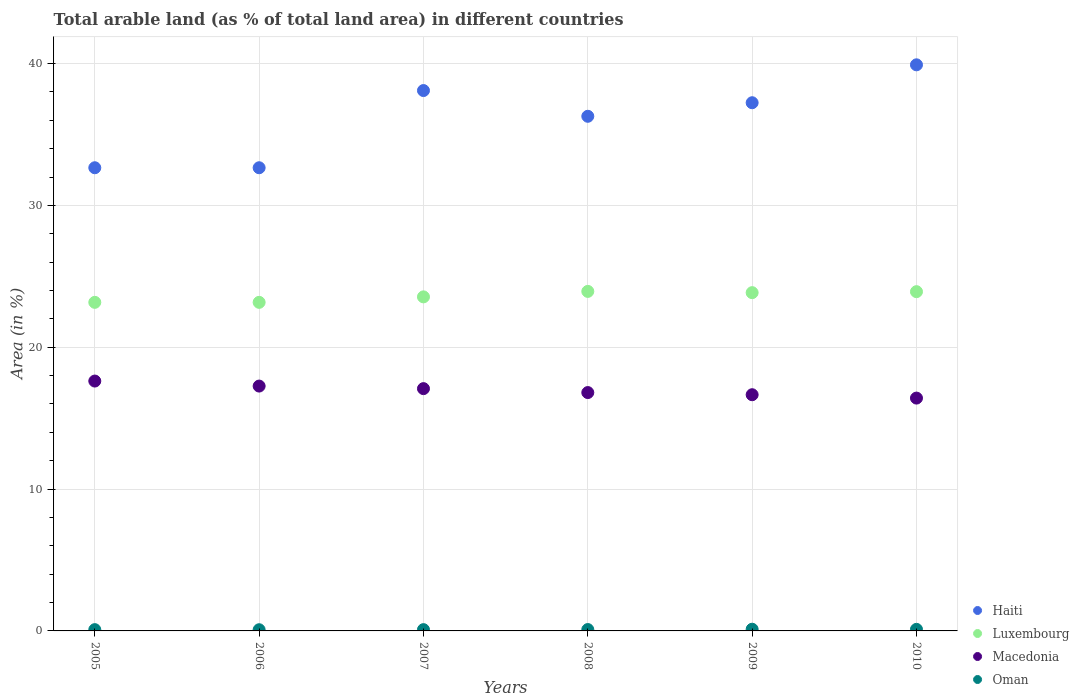What is the percentage of arable land in Oman in 2005?
Offer a very short reply. 0.09. Across all years, what is the maximum percentage of arable land in Haiti?
Make the answer very short. 39.91. Across all years, what is the minimum percentage of arable land in Macedonia?
Your answer should be very brief. 16.42. In which year was the percentage of arable land in Haiti minimum?
Keep it short and to the point. 2005. What is the total percentage of arable land in Luxembourg in the graph?
Keep it short and to the point. 141.59. What is the difference between the percentage of arable land in Luxembourg in 2008 and that in 2010?
Offer a terse response. 0.02. What is the difference between the percentage of arable land in Macedonia in 2007 and the percentage of arable land in Oman in 2009?
Your answer should be compact. 16.96. What is the average percentage of arable land in Luxembourg per year?
Provide a succinct answer. 23.6. In the year 2008, what is the difference between the percentage of arable land in Haiti and percentage of arable land in Macedonia?
Provide a short and direct response. 19.48. What is the ratio of the percentage of arable land in Macedonia in 2008 to that in 2010?
Make the answer very short. 1.02. Is the percentage of arable land in Oman in 2009 less than that in 2010?
Make the answer very short. No. What is the difference between the highest and the second highest percentage of arable land in Luxembourg?
Make the answer very short. 0.02. What is the difference between the highest and the lowest percentage of arable land in Haiti?
Your response must be concise. 7.26. In how many years, is the percentage of arable land in Macedonia greater than the average percentage of arable land in Macedonia taken over all years?
Ensure brevity in your answer.  3. Is it the case that in every year, the sum of the percentage of arable land in Macedonia and percentage of arable land in Luxembourg  is greater than the sum of percentage of arable land in Haiti and percentage of arable land in Oman?
Make the answer very short. Yes. Is it the case that in every year, the sum of the percentage of arable land in Oman and percentage of arable land in Haiti  is greater than the percentage of arable land in Luxembourg?
Your response must be concise. Yes. Does the percentage of arable land in Oman monotonically increase over the years?
Your answer should be compact. No. Is the percentage of arable land in Haiti strictly greater than the percentage of arable land in Luxembourg over the years?
Provide a short and direct response. Yes. Is the percentage of arable land in Oman strictly less than the percentage of arable land in Haiti over the years?
Make the answer very short. Yes. Does the graph contain any zero values?
Keep it short and to the point. No. Does the graph contain grids?
Keep it short and to the point. Yes. How many legend labels are there?
Offer a terse response. 4. What is the title of the graph?
Provide a succinct answer. Total arable land (as % of total land area) in different countries. Does "Guinea" appear as one of the legend labels in the graph?
Your answer should be very brief. No. What is the label or title of the Y-axis?
Give a very brief answer. Area (in %). What is the Area (in %) of Haiti in 2005?
Ensure brevity in your answer.  32.66. What is the Area (in %) of Luxembourg in 2005?
Offer a very short reply. 23.17. What is the Area (in %) in Macedonia in 2005?
Give a very brief answer. 17.62. What is the Area (in %) of Oman in 2005?
Your answer should be compact. 0.09. What is the Area (in %) in Haiti in 2006?
Your answer should be compact. 32.66. What is the Area (in %) in Luxembourg in 2006?
Your answer should be very brief. 23.17. What is the Area (in %) of Macedonia in 2006?
Provide a succinct answer. 17.26. What is the Area (in %) of Oman in 2006?
Your response must be concise. 0.08. What is the Area (in %) in Haiti in 2007?
Make the answer very short. 38.1. What is the Area (in %) in Luxembourg in 2007?
Provide a succinct answer. 23.55. What is the Area (in %) in Macedonia in 2007?
Make the answer very short. 17.08. What is the Area (in %) of Oman in 2007?
Your response must be concise. 0.09. What is the Area (in %) in Haiti in 2008?
Keep it short and to the point. 36.28. What is the Area (in %) in Luxembourg in 2008?
Offer a very short reply. 23.94. What is the Area (in %) in Macedonia in 2008?
Keep it short and to the point. 16.81. What is the Area (in %) in Oman in 2008?
Provide a short and direct response. 0.1. What is the Area (in %) in Haiti in 2009?
Your answer should be very brief. 37.24. What is the Area (in %) in Luxembourg in 2009?
Your answer should be compact. 23.85. What is the Area (in %) of Macedonia in 2009?
Offer a very short reply. 16.65. What is the Area (in %) of Oman in 2009?
Offer a terse response. 0.12. What is the Area (in %) in Haiti in 2010?
Your response must be concise. 39.91. What is the Area (in %) of Luxembourg in 2010?
Provide a succinct answer. 23.92. What is the Area (in %) in Macedonia in 2010?
Provide a succinct answer. 16.42. What is the Area (in %) in Oman in 2010?
Ensure brevity in your answer.  0.11. Across all years, what is the maximum Area (in %) of Haiti?
Offer a very short reply. 39.91. Across all years, what is the maximum Area (in %) of Luxembourg?
Offer a very short reply. 23.94. Across all years, what is the maximum Area (in %) of Macedonia?
Make the answer very short. 17.62. Across all years, what is the maximum Area (in %) of Oman?
Give a very brief answer. 0.12. Across all years, what is the minimum Area (in %) of Haiti?
Keep it short and to the point. 32.66. Across all years, what is the minimum Area (in %) in Luxembourg?
Keep it short and to the point. 23.17. Across all years, what is the minimum Area (in %) in Macedonia?
Your answer should be compact. 16.42. Across all years, what is the minimum Area (in %) in Oman?
Make the answer very short. 0.08. What is the total Area (in %) of Haiti in the graph?
Offer a terse response. 216.85. What is the total Area (in %) of Luxembourg in the graph?
Make the answer very short. 141.59. What is the total Area (in %) in Macedonia in the graph?
Offer a very short reply. 101.84. What is the total Area (in %) of Oman in the graph?
Make the answer very short. 0.59. What is the difference between the Area (in %) of Haiti in 2005 and that in 2006?
Make the answer very short. 0. What is the difference between the Area (in %) in Luxembourg in 2005 and that in 2006?
Offer a terse response. 0. What is the difference between the Area (in %) of Macedonia in 2005 and that in 2006?
Provide a short and direct response. 0.35. What is the difference between the Area (in %) in Oman in 2005 and that in 2006?
Your answer should be very brief. 0.01. What is the difference between the Area (in %) in Haiti in 2005 and that in 2007?
Offer a very short reply. -5.44. What is the difference between the Area (in %) in Luxembourg in 2005 and that in 2007?
Your answer should be compact. -0.39. What is the difference between the Area (in %) in Macedonia in 2005 and that in 2007?
Ensure brevity in your answer.  0.53. What is the difference between the Area (in %) in Oman in 2005 and that in 2007?
Offer a terse response. 0. What is the difference between the Area (in %) in Haiti in 2005 and that in 2008?
Provide a succinct answer. -3.63. What is the difference between the Area (in %) in Luxembourg in 2005 and that in 2008?
Offer a terse response. -0.77. What is the difference between the Area (in %) in Macedonia in 2005 and that in 2008?
Keep it short and to the point. 0.81. What is the difference between the Area (in %) of Oman in 2005 and that in 2008?
Give a very brief answer. -0.01. What is the difference between the Area (in %) in Haiti in 2005 and that in 2009?
Offer a very short reply. -4.58. What is the difference between the Area (in %) in Luxembourg in 2005 and that in 2009?
Your answer should be compact. -0.68. What is the difference between the Area (in %) in Macedonia in 2005 and that in 2009?
Keep it short and to the point. 0.96. What is the difference between the Area (in %) of Oman in 2005 and that in 2009?
Your answer should be very brief. -0.03. What is the difference between the Area (in %) in Haiti in 2005 and that in 2010?
Your response must be concise. -7.26. What is the difference between the Area (in %) in Luxembourg in 2005 and that in 2010?
Your response must be concise. -0.75. What is the difference between the Area (in %) in Macedonia in 2005 and that in 2010?
Your answer should be compact. 1.2. What is the difference between the Area (in %) of Oman in 2005 and that in 2010?
Offer a terse response. -0.02. What is the difference between the Area (in %) in Haiti in 2006 and that in 2007?
Keep it short and to the point. -5.44. What is the difference between the Area (in %) in Luxembourg in 2006 and that in 2007?
Make the answer very short. -0.39. What is the difference between the Area (in %) of Macedonia in 2006 and that in 2007?
Ensure brevity in your answer.  0.18. What is the difference between the Area (in %) of Oman in 2006 and that in 2007?
Provide a short and direct response. -0.01. What is the difference between the Area (in %) in Haiti in 2006 and that in 2008?
Ensure brevity in your answer.  -3.63. What is the difference between the Area (in %) of Luxembourg in 2006 and that in 2008?
Ensure brevity in your answer.  -0.77. What is the difference between the Area (in %) in Macedonia in 2006 and that in 2008?
Your answer should be very brief. 0.46. What is the difference between the Area (in %) in Oman in 2006 and that in 2008?
Provide a short and direct response. -0.01. What is the difference between the Area (in %) in Haiti in 2006 and that in 2009?
Ensure brevity in your answer.  -4.58. What is the difference between the Area (in %) in Luxembourg in 2006 and that in 2009?
Provide a short and direct response. -0.68. What is the difference between the Area (in %) in Macedonia in 2006 and that in 2009?
Give a very brief answer. 0.61. What is the difference between the Area (in %) of Oman in 2006 and that in 2009?
Offer a terse response. -0.04. What is the difference between the Area (in %) in Haiti in 2006 and that in 2010?
Make the answer very short. -7.26. What is the difference between the Area (in %) of Luxembourg in 2006 and that in 2010?
Keep it short and to the point. -0.75. What is the difference between the Area (in %) of Macedonia in 2006 and that in 2010?
Provide a succinct answer. 0.85. What is the difference between the Area (in %) in Oman in 2006 and that in 2010?
Keep it short and to the point. -0.03. What is the difference between the Area (in %) of Haiti in 2007 and that in 2008?
Your answer should be compact. 1.81. What is the difference between the Area (in %) of Luxembourg in 2007 and that in 2008?
Your response must be concise. -0.39. What is the difference between the Area (in %) in Macedonia in 2007 and that in 2008?
Provide a succinct answer. 0.28. What is the difference between the Area (in %) of Oman in 2007 and that in 2008?
Ensure brevity in your answer.  -0.01. What is the difference between the Area (in %) in Haiti in 2007 and that in 2009?
Provide a short and direct response. 0.86. What is the difference between the Area (in %) of Luxembourg in 2007 and that in 2009?
Offer a very short reply. -0.3. What is the difference between the Area (in %) of Macedonia in 2007 and that in 2009?
Ensure brevity in your answer.  0.43. What is the difference between the Area (in %) of Oman in 2007 and that in 2009?
Offer a very short reply. -0.03. What is the difference between the Area (in %) of Haiti in 2007 and that in 2010?
Your response must be concise. -1.81. What is the difference between the Area (in %) of Luxembourg in 2007 and that in 2010?
Provide a short and direct response. -0.37. What is the difference between the Area (in %) of Macedonia in 2007 and that in 2010?
Ensure brevity in your answer.  0.67. What is the difference between the Area (in %) in Oman in 2007 and that in 2010?
Offer a terse response. -0.02. What is the difference between the Area (in %) in Haiti in 2008 and that in 2009?
Your response must be concise. -0.96. What is the difference between the Area (in %) in Luxembourg in 2008 and that in 2009?
Offer a very short reply. 0.09. What is the difference between the Area (in %) in Macedonia in 2008 and that in 2009?
Ensure brevity in your answer.  0.15. What is the difference between the Area (in %) in Oman in 2008 and that in 2009?
Provide a succinct answer. -0.02. What is the difference between the Area (in %) in Haiti in 2008 and that in 2010?
Offer a very short reply. -3.63. What is the difference between the Area (in %) in Luxembourg in 2008 and that in 2010?
Ensure brevity in your answer.  0.02. What is the difference between the Area (in %) of Macedonia in 2008 and that in 2010?
Provide a short and direct response. 0.39. What is the difference between the Area (in %) of Oman in 2008 and that in 2010?
Your answer should be compact. -0.01. What is the difference between the Area (in %) of Haiti in 2009 and that in 2010?
Offer a very short reply. -2.67. What is the difference between the Area (in %) in Luxembourg in 2009 and that in 2010?
Provide a succinct answer. -0.07. What is the difference between the Area (in %) in Macedonia in 2009 and that in 2010?
Keep it short and to the point. 0.24. What is the difference between the Area (in %) in Oman in 2009 and that in 2010?
Offer a very short reply. 0.01. What is the difference between the Area (in %) in Haiti in 2005 and the Area (in %) in Luxembourg in 2006?
Keep it short and to the point. 9.49. What is the difference between the Area (in %) of Haiti in 2005 and the Area (in %) of Macedonia in 2006?
Provide a short and direct response. 15.39. What is the difference between the Area (in %) of Haiti in 2005 and the Area (in %) of Oman in 2006?
Give a very brief answer. 32.57. What is the difference between the Area (in %) of Luxembourg in 2005 and the Area (in %) of Macedonia in 2006?
Your answer should be very brief. 5.9. What is the difference between the Area (in %) in Luxembourg in 2005 and the Area (in %) in Oman in 2006?
Provide a succinct answer. 23.08. What is the difference between the Area (in %) of Macedonia in 2005 and the Area (in %) of Oman in 2006?
Keep it short and to the point. 17.53. What is the difference between the Area (in %) in Haiti in 2005 and the Area (in %) in Luxembourg in 2007?
Ensure brevity in your answer.  9.1. What is the difference between the Area (in %) in Haiti in 2005 and the Area (in %) in Macedonia in 2007?
Make the answer very short. 15.57. What is the difference between the Area (in %) of Haiti in 2005 and the Area (in %) of Oman in 2007?
Offer a very short reply. 32.57. What is the difference between the Area (in %) of Luxembourg in 2005 and the Area (in %) of Macedonia in 2007?
Your response must be concise. 6.08. What is the difference between the Area (in %) in Luxembourg in 2005 and the Area (in %) in Oman in 2007?
Ensure brevity in your answer.  23.08. What is the difference between the Area (in %) in Macedonia in 2005 and the Area (in %) in Oman in 2007?
Keep it short and to the point. 17.53. What is the difference between the Area (in %) in Haiti in 2005 and the Area (in %) in Luxembourg in 2008?
Make the answer very short. 8.72. What is the difference between the Area (in %) in Haiti in 2005 and the Area (in %) in Macedonia in 2008?
Keep it short and to the point. 15.85. What is the difference between the Area (in %) of Haiti in 2005 and the Area (in %) of Oman in 2008?
Keep it short and to the point. 32.56. What is the difference between the Area (in %) of Luxembourg in 2005 and the Area (in %) of Macedonia in 2008?
Offer a terse response. 6.36. What is the difference between the Area (in %) in Luxembourg in 2005 and the Area (in %) in Oman in 2008?
Your response must be concise. 23.07. What is the difference between the Area (in %) in Macedonia in 2005 and the Area (in %) in Oman in 2008?
Provide a succinct answer. 17.52. What is the difference between the Area (in %) in Haiti in 2005 and the Area (in %) in Luxembourg in 2009?
Give a very brief answer. 8.81. What is the difference between the Area (in %) of Haiti in 2005 and the Area (in %) of Macedonia in 2009?
Your answer should be compact. 16. What is the difference between the Area (in %) of Haiti in 2005 and the Area (in %) of Oman in 2009?
Provide a short and direct response. 32.54. What is the difference between the Area (in %) of Luxembourg in 2005 and the Area (in %) of Macedonia in 2009?
Ensure brevity in your answer.  6.51. What is the difference between the Area (in %) of Luxembourg in 2005 and the Area (in %) of Oman in 2009?
Make the answer very short. 23.05. What is the difference between the Area (in %) of Macedonia in 2005 and the Area (in %) of Oman in 2009?
Your answer should be compact. 17.5. What is the difference between the Area (in %) of Haiti in 2005 and the Area (in %) of Luxembourg in 2010?
Give a very brief answer. 8.74. What is the difference between the Area (in %) in Haiti in 2005 and the Area (in %) in Macedonia in 2010?
Ensure brevity in your answer.  16.24. What is the difference between the Area (in %) of Haiti in 2005 and the Area (in %) of Oman in 2010?
Make the answer very short. 32.55. What is the difference between the Area (in %) in Luxembourg in 2005 and the Area (in %) in Macedonia in 2010?
Offer a very short reply. 6.75. What is the difference between the Area (in %) in Luxembourg in 2005 and the Area (in %) in Oman in 2010?
Offer a terse response. 23.06. What is the difference between the Area (in %) of Macedonia in 2005 and the Area (in %) of Oman in 2010?
Your answer should be very brief. 17.51. What is the difference between the Area (in %) in Haiti in 2006 and the Area (in %) in Luxembourg in 2007?
Ensure brevity in your answer.  9.1. What is the difference between the Area (in %) of Haiti in 2006 and the Area (in %) of Macedonia in 2007?
Your answer should be very brief. 15.57. What is the difference between the Area (in %) in Haiti in 2006 and the Area (in %) in Oman in 2007?
Your answer should be compact. 32.57. What is the difference between the Area (in %) in Luxembourg in 2006 and the Area (in %) in Macedonia in 2007?
Offer a very short reply. 6.08. What is the difference between the Area (in %) in Luxembourg in 2006 and the Area (in %) in Oman in 2007?
Your answer should be very brief. 23.08. What is the difference between the Area (in %) of Macedonia in 2006 and the Area (in %) of Oman in 2007?
Make the answer very short. 17.17. What is the difference between the Area (in %) of Haiti in 2006 and the Area (in %) of Luxembourg in 2008?
Keep it short and to the point. 8.72. What is the difference between the Area (in %) in Haiti in 2006 and the Area (in %) in Macedonia in 2008?
Ensure brevity in your answer.  15.85. What is the difference between the Area (in %) of Haiti in 2006 and the Area (in %) of Oman in 2008?
Make the answer very short. 32.56. What is the difference between the Area (in %) in Luxembourg in 2006 and the Area (in %) in Macedonia in 2008?
Offer a terse response. 6.36. What is the difference between the Area (in %) in Luxembourg in 2006 and the Area (in %) in Oman in 2008?
Offer a terse response. 23.07. What is the difference between the Area (in %) in Macedonia in 2006 and the Area (in %) in Oman in 2008?
Your answer should be very brief. 17.17. What is the difference between the Area (in %) of Haiti in 2006 and the Area (in %) of Luxembourg in 2009?
Give a very brief answer. 8.81. What is the difference between the Area (in %) in Haiti in 2006 and the Area (in %) in Macedonia in 2009?
Provide a short and direct response. 16. What is the difference between the Area (in %) in Haiti in 2006 and the Area (in %) in Oman in 2009?
Offer a terse response. 32.54. What is the difference between the Area (in %) of Luxembourg in 2006 and the Area (in %) of Macedonia in 2009?
Ensure brevity in your answer.  6.51. What is the difference between the Area (in %) of Luxembourg in 2006 and the Area (in %) of Oman in 2009?
Provide a short and direct response. 23.05. What is the difference between the Area (in %) of Macedonia in 2006 and the Area (in %) of Oman in 2009?
Keep it short and to the point. 17.14. What is the difference between the Area (in %) in Haiti in 2006 and the Area (in %) in Luxembourg in 2010?
Offer a terse response. 8.74. What is the difference between the Area (in %) in Haiti in 2006 and the Area (in %) in Macedonia in 2010?
Ensure brevity in your answer.  16.24. What is the difference between the Area (in %) of Haiti in 2006 and the Area (in %) of Oman in 2010?
Keep it short and to the point. 32.55. What is the difference between the Area (in %) in Luxembourg in 2006 and the Area (in %) in Macedonia in 2010?
Your answer should be very brief. 6.75. What is the difference between the Area (in %) in Luxembourg in 2006 and the Area (in %) in Oman in 2010?
Provide a succinct answer. 23.06. What is the difference between the Area (in %) in Macedonia in 2006 and the Area (in %) in Oman in 2010?
Ensure brevity in your answer.  17.15. What is the difference between the Area (in %) of Haiti in 2007 and the Area (in %) of Luxembourg in 2008?
Keep it short and to the point. 14.16. What is the difference between the Area (in %) of Haiti in 2007 and the Area (in %) of Macedonia in 2008?
Offer a terse response. 21.29. What is the difference between the Area (in %) of Haiti in 2007 and the Area (in %) of Oman in 2008?
Keep it short and to the point. 38. What is the difference between the Area (in %) of Luxembourg in 2007 and the Area (in %) of Macedonia in 2008?
Offer a terse response. 6.75. What is the difference between the Area (in %) of Luxembourg in 2007 and the Area (in %) of Oman in 2008?
Provide a succinct answer. 23.46. What is the difference between the Area (in %) of Macedonia in 2007 and the Area (in %) of Oman in 2008?
Your answer should be compact. 16.99. What is the difference between the Area (in %) of Haiti in 2007 and the Area (in %) of Luxembourg in 2009?
Your answer should be compact. 14.25. What is the difference between the Area (in %) of Haiti in 2007 and the Area (in %) of Macedonia in 2009?
Give a very brief answer. 21.45. What is the difference between the Area (in %) in Haiti in 2007 and the Area (in %) in Oman in 2009?
Your response must be concise. 37.98. What is the difference between the Area (in %) in Luxembourg in 2007 and the Area (in %) in Macedonia in 2009?
Your answer should be compact. 6.9. What is the difference between the Area (in %) in Luxembourg in 2007 and the Area (in %) in Oman in 2009?
Your response must be concise. 23.43. What is the difference between the Area (in %) of Macedonia in 2007 and the Area (in %) of Oman in 2009?
Offer a terse response. 16.96. What is the difference between the Area (in %) of Haiti in 2007 and the Area (in %) of Luxembourg in 2010?
Provide a succinct answer. 14.18. What is the difference between the Area (in %) in Haiti in 2007 and the Area (in %) in Macedonia in 2010?
Keep it short and to the point. 21.68. What is the difference between the Area (in %) in Haiti in 2007 and the Area (in %) in Oman in 2010?
Keep it short and to the point. 37.99. What is the difference between the Area (in %) of Luxembourg in 2007 and the Area (in %) of Macedonia in 2010?
Offer a terse response. 7.14. What is the difference between the Area (in %) in Luxembourg in 2007 and the Area (in %) in Oman in 2010?
Your answer should be very brief. 23.44. What is the difference between the Area (in %) of Macedonia in 2007 and the Area (in %) of Oman in 2010?
Keep it short and to the point. 16.97. What is the difference between the Area (in %) in Haiti in 2008 and the Area (in %) in Luxembourg in 2009?
Provide a short and direct response. 12.44. What is the difference between the Area (in %) of Haiti in 2008 and the Area (in %) of Macedonia in 2009?
Offer a terse response. 19.63. What is the difference between the Area (in %) in Haiti in 2008 and the Area (in %) in Oman in 2009?
Provide a succinct answer. 36.16. What is the difference between the Area (in %) in Luxembourg in 2008 and the Area (in %) in Macedonia in 2009?
Keep it short and to the point. 7.28. What is the difference between the Area (in %) in Luxembourg in 2008 and the Area (in %) in Oman in 2009?
Provide a succinct answer. 23.82. What is the difference between the Area (in %) of Macedonia in 2008 and the Area (in %) of Oman in 2009?
Your answer should be very brief. 16.69. What is the difference between the Area (in %) in Haiti in 2008 and the Area (in %) in Luxembourg in 2010?
Your response must be concise. 12.37. What is the difference between the Area (in %) in Haiti in 2008 and the Area (in %) in Macedonia in 2010?
Make the answer very short. 19.87. What is the difference between the Area (in %) of Haiti in 2008 and the Area (in %) of Oman in 2010?
Keep it short and to the point. 36.17. What is the difference between the Area (in %) of Luxembourg in 2008 and the Area (in %) of Macedonia in 2010?
Ensure brevity in your answer.  7.52. What is the difference between the Area (in %) of Luxembourg in 2008 and the Area (in %) of Oman in 2010?
Your answer should be very brief. 23.83. What is the difference between the Area (in %) of Macedonia in 2008 and the Area (in %) of Oman in 2010?
Provide a succinct answer. 16.69. What is the difference between the Area (in %) of Haiti in 2009 and the Area (in %) of Luxembourg in 2010?
Your answer should be compact. 13.32. What is the difference between the Area (in %) in Haiti in 2009 and the Area (in %) in Macedonia in 2010?
Provide a short and direct response. 20.82. What is the difference between the Area (in %) in Haiti in 2009 and the Area (in %) in Oman in 2010?
Give a very brief answer. 37.13. What is the difference between the Area (in %) of Luxembourg in 2009 and the Area (in %) of Macedonia in 2010?
Make the answer very short. 7.43. What is the difference between the Area (in %) of Luxembourg in 2009 and the Area (in %) of Oman in 2010?
Give a very brief answer. 23.74. What is the difference between the Area (in %) of Macedonia in 2009 and the Area (in %) of Oman in 2010?
Make the answer very short. 16.54. What is the average Area (in %) of Haiti per year?
Ensure brevity in your answer.  36.14. What is the average Area (in %) in Luxembourg per year?
Provide a short and direct response. 23.6. What is the average Area (in %) in Macedonia per year?
Ensure brevity in your answer.  16.97. What is the average Area (in %) of Oman per year?
Ensure brevity in your answer.  0.1. In the year 2005, what is the difference between the Area (in %) in Haiti and Area (in %) in Luxembourg?
Provide a short and direct response. 9.49. In the year 2005, what is the difference between the Area (in %) of Haiti and Area (in %) of Macedonia?
Give a very brief answer. 15.04. In the year 2005, what is the difference between the Area (in %) of Haiti and Area (in %) of Oman?
Provide a succinct answer. 32.57. In the year 2005, what is the difference between the Area (in %) of Luxembourg and Area (in %) of Macedonia?
Make the answer very short. 5.55. In the year 2005, what is the difference between the Area (in %) in Luxembourg and Area (in %) in Oman?
Provide a succinct answer. 23.08. In the year 2005, what is the difference between the Area (in %) of Macedonia and Area (in %) of Oman?
Provide a short and direct response. 17.53. In the year 2006, what is the difference between the Area (in %) in Haiti and Area (in %) in Luxembourg?
Give a very brief answer. 9.49. In the year 2006, what is the difference between the Area (in %) in Haiti and Area (in %) in Macedonia?
Offer a very short reply. 15.39. In the year 2006, what is the difference between the Area (in %) of Haiti and Area (in %) of Oman?
Give a very brief answer. 32.57. In the year 2006, what is the difference between the Area (in %) in Luxembourg and Area (in %) in Macedonia?
Provide a short and direct response. 5.9. In the year 2006, what is the difference between the Area (in %) of Luxembourg and Area (in %) of Oman?
Make the answer very short. 23.08. In the year 2006, what is the difference between the Area (in %) in Macedonia and Area (in %) in Oman?
Your answer should be very brief. 17.18. In the year 2007, what is the difference between the Area (in %) of Haiti and Area (in %) of Luxembourg?
Offer a terse response. 14.55. In the year 2007, what is the difference between the Area (in %) in Haiti and Area (in %) in Macedonia?
Your response must be concise. 21.02. In the year 2007, what is the difference between the Area (in %) of Haiti and Area (in %) of Oman?
Make the answer very short. 38.01. In the year 2007, what is the difference between the Area (in %) of Luxembourg and Area (in %) of Macedonia?
Give a very brief answer. 6.47. In the year 2007, what is the difference between the Area (in %) in Luxembourg and Area (in %) in Oman?
Ensure brevity in your answer.  23.46. In the year 2007, what is the difference between the Area (in %) in Macedonia and Area (in %) in Oman?
Keep it short and to the point. 16.99. In the year 2008, what is the difference between the Area (in %) of Haiti and Area (in %) of Luxembourg?
Your answer should be compact. 12.35. In the year 2008, what is the difference between the Area (in %) of Haiti and Area (in %) of Macedonia?
Provide a short and direct response. 19.48. In the year 2008, what is the difference between the Area (in %) of Haiti and Area (in %) of Oman?
Make the answer very short. 36.19. In the year 2008, what is the difference between the Area (in %) in Luxembourg and Area (in %) in Macedonia?
Provide a short and direct response. 7.13. In the year 2008, what is the difference between the Area (in %) in Luxembourg and Area (in %) in Oman?
Ensure brevity in your answer.  23.84. In the year 2008, what is the difference between the Area (in %) of Macedonia and Area (in %) of Oman?
Ensure brevity in your answer.  16.71. In the year 2009, what is the difference between the Area (in %) of Haiti and Area (in %) of Luxembourg?
Provide a short and direct response. 13.39. In the year 2009, what is the difference between the Area (in %) in Haiti and Area (in %) in Macedonia?
Provide a short and direct response. 20.59. In the year 2009, what is the difference between the Area (in %) of Haiti and Area (in %) of Oman?
Offer a terse response. 37.12. In the year 2009, what is the difference between the Area (in %) of Luxembourg and Area (in %) of Macedonia?
Keep it short and to the point. 7.2. In the year 2009, what is the difference between the Area (in %) in Luxembourg and Area (in %) in Oman?
Your answer should be compact. 23.73. In the year 2009, what is the difference between the Area (in %) in Macedonia and Area (in %) in Oman?
Offer a very short reply. 16.53. In the year 2010, what is the difference between the Area (in %) in Haiti and Area (in %) in Luxembourg?
Your response must be concise. 15.99. In the year 2010, what is the difference between the Area (in %) of Haiti and Area (in %) of Macedonia?
Ensure brevity in your answer.  23.5. In the year 2010, what is the difference between the Area (in %) in Haiti and Area (in %) in Oman?
Your response must be concise. 39.8. In the year 2010, what is the difference between the Area (in %) of Luxembourg and Area (in %) of Macedonia?
Offer a very short reply. 7.5. In the year 2010, what is the difference between the Area (in %) in Luxembourg and Area (in %) in Oman?
Offer a very short reply. 23.81. In the year 2010, what is the difference between the Area (in %) in Macedonia and Area (in %) in Oman?
Ensure brevity in your answer.  16.3. What is the ratio of the Area (in %) of Haiti in 2005 to that in 2006?
Your answer should be very brief. 1. What is the ratio of the Area (in %) in Macedonia in 2005 to that in 2006?
Make the answer very short. 1.02. What is the ratio of the Area (in %) in Haiti in 2005 to that in 2007?
Your response must be concise. 0.86. What is the ratio of the Area (in %) of Luxembourg in 2005 to that in 2007?
Offer a terse response. 0.98. What is the ratio of the Area (in %) of Macedonia in 2005 to that in 2007?
Make the answer very short. 1.03. What is the ratio of the Area (in %) of Macedonia in 2005 to that in 2008?
Offer a very short reply. 1.05. What is the ratio of the Area (in %) of Haiti in 2005 to that in 2009?
Ensure brevity in your answer.  0.88. What is the ratio of the Area (in %) of Luxembourg in 2005 to that in 2009?
Keep it short and to the point. 0.97. What is the ratio of the Area (in %) in Macedonia in 2005 to that in 2009?
Your answer should be very brief. 1.06. What is the ratio of the Area (in %) in Oman in 2005 to that in 2009?
Offer a terse response. 0.76. What is the ratio of the Area (in %) of Haiti in 2005 to that in 2010?
Ensure brevity in your answer.  0.82. What is the ratio of the Area (in %) of Luxembourg in 2005 to that in 2010?
Keep it short and to the point. 0.97. What is the ratio of the Area (in %) of Macedonia in 2005 to that in 2010?
Your response must be concise. 1.07. What is the ratio of the Area (in %) of Oman in 2005 to that in 2010?
Your answer should be compact. 0.82. What is the ratio of the Area (in %) of Luxembourg in 2006 to that in 2007?
Your answer should be compact. 0.98. What is the ratio of the Area (in %) in Macedonia in 2006 to that in 2007?
Your answer should be very brief. 1.01. What is the ratio of the Area (in %) in Haiti in 2006 to that in 2008?
Make the answer very short. 0.9. What is the ratio of the Area (in %) in Luxembourg in 2006 to that in 2008?
Ensure brevity in your answer.  0.97. What is the ratio of the Area (in %) of Macedonia in 2006 to that in 2008?
Your answer should be compact. 1.03. What is the ratio of the Area (in %) in Oman in 2006 to that in 2008?
Ensure brevity in your answer.  0.87. What is the ratio of the Area (in %) in Haiti in 2006 to that in 2009?
Ensure brevity in your answer.  0.88. What is the ratio of the Area (in %) of Luxembourg in 2006 to that in 2009?
Provide a short and direct response. 0.97. What is the ratio of the Area (in %) of Macedonia in 2006 to that in 2009?
Provide a short and direct response. 1.04. What is the ratio of the Area (in %) in Oman in 2006 to that in 2009?
Make the answer very short. 0.7. What is the ratio of the Area (in %) in Haiti in 2006 to that in 2010?
Provide a short and direct response. 0.82. What is the ratio of the Area (in %) in Luxembourg in 2006 to that in 2010?
Your answer should be compact. 0.97. What is the ratio of the Area (in %) of Macedonia in 2006 to that in 2010?
Your response must be concise. 1.05. What is the ratio of the Area (in %) of Oman in 2006 to that in 2010?
Offer a very short reply. 0.76. What is the ratio of the Area (in %) in Haiti in 2007 to that in 2008?
Your answer should be very brief. 1.05. What is the ratio of the Area (in %) of Luxembourg in 2007 to that in 2008?
Give a very brief answer. 0.98. What is the ratio of the Area (in %) in Macedonia in 2007 to that in 2008?
Keep it short and to the point. 1.02. What is the ratio of the Area (in %) in Oman in 2007 to that in 2008?
Your answer should be very brief. 0.93. What is the ratio of the Area (in %) in Haiti in 2007 to that in 2009?
Your response must be concise. 1.02. What is the ratio of the Area (in %) in Luxembourg in 2007 to that in 2009?
Your answer should be compact. 0.99. What is the ratio of the Area (in %) in Macedonia in 2007 to that in 2009?
Your answer should be very brief. 1.03. What is the ratio of the Area (in %) in Oman in 2007 to that in 2009?
Keep it short and to the point. 0.76. What is the ratio of the Area (in %) of Haiti in 2007 to that in 2010?
Provide a short and direct response. 0.95. What is the ratio of the Area (in %) in Luxembourg in 2007 to that in 2010?
Provide a succinct answer. 0.98. What is the ratio of the Area (in %) of Macedonia in 2007 to that in 2010?
Ensure brevity in your answer.  1.04. What is the ratio of the Area (in %) of Oman in 2007 to that in 2010?
Offer a terse response. 0.82. What is the ratio of the Area (in %) of Haiti in 2008 to that in 2009?
Offer a very short reply. 0.97. What is the ratio of the Area (in %) of Macedonia in 2008 to that in 2009?
Offer a very short reply. 1.01. What is the ratio of the Area (in %) in Oman in 2008 to that in 2009?
Offer a terse response. 0.81. What is the ratio of the Area (in %) in Haiti in 2008 to that in 2010?
Give a very brief answer. 0.91. What is the ratio of the Area (in %) in Luxembourg in 2008 to that in 2010?
Provide a succinct answer. 1. What is the ratio of the Area (in %) of Macedonia in 2008 to that in 2010?
Your answer should be very brief. 1.02. What is the ratio of the Area (in %) of Oman in 2008 to that in 2010?
Offer a terse response. 0.87. What is the ratio of the Area (in %) in Haiti in 2009 to that in 2010?
Your response must be concise. 0.93. What is the ratio of the Area (in %) of Macedonia in 2009 to that in 2010?
Your answer should be compact. 1.01. What is the ratio of the Area (in %) of Oman in 2009 to that in 2010?
Offer a terse response. 1.08. What is the difference between the highest and the second highest Area (in %) of Haiti?
Provide a succinct answer. 1.81. What is the difference between the highest and the second highest Area (in %) in Luxembourg?
Your answer should be very brief. 0.02. What is the difference between the highest and the second highest Area (in %) of Macedonia?
Your answer should be compact. 0.35. What is the difference between the highest and the second highest Area (in %) in Oman?
Provide a succinct answer. 0.01. What is the difference between the highest and the lowest Area (in %) of Haiti?
Provide a succinct answer. 7.26. What is the difference between the highest and the lowest Area (in %) in Luxembourg?
Provide a succinct answer. 0.77. What is the difference between the highest and the lowest Area (in %) in Macedonia?
Your response must be concise. 1.2. What is the difference between the highest and the lowest Area (in %) in Oman?
Your response must be concise. 0.04. 